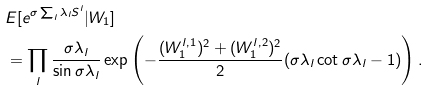Convert formula to latex. <formula><loc_0><loc_0><loc_500><loc_500>& E [ e ^ { \sigma \sum _ { l } \lambda _ { l } S ^ { l } } | W _ { 1 } ] \\ & = \prod _ { l } \frac { { \sigma \lambda } _ { l } } { \sin { \sigma \lambda } _ { l } } \exp \left ( - \frac { ( W ^ { l , 1 } _ { 1 } ) ^ { 2 } + ( W ^ { l , 2 } _ { 1 } ) ^ { 2 } } { 2 } ( { \sigma \lambda } _ { l } \cot { \sigma \lambda } _ { l } - 1 ) \right ) .</formula> 